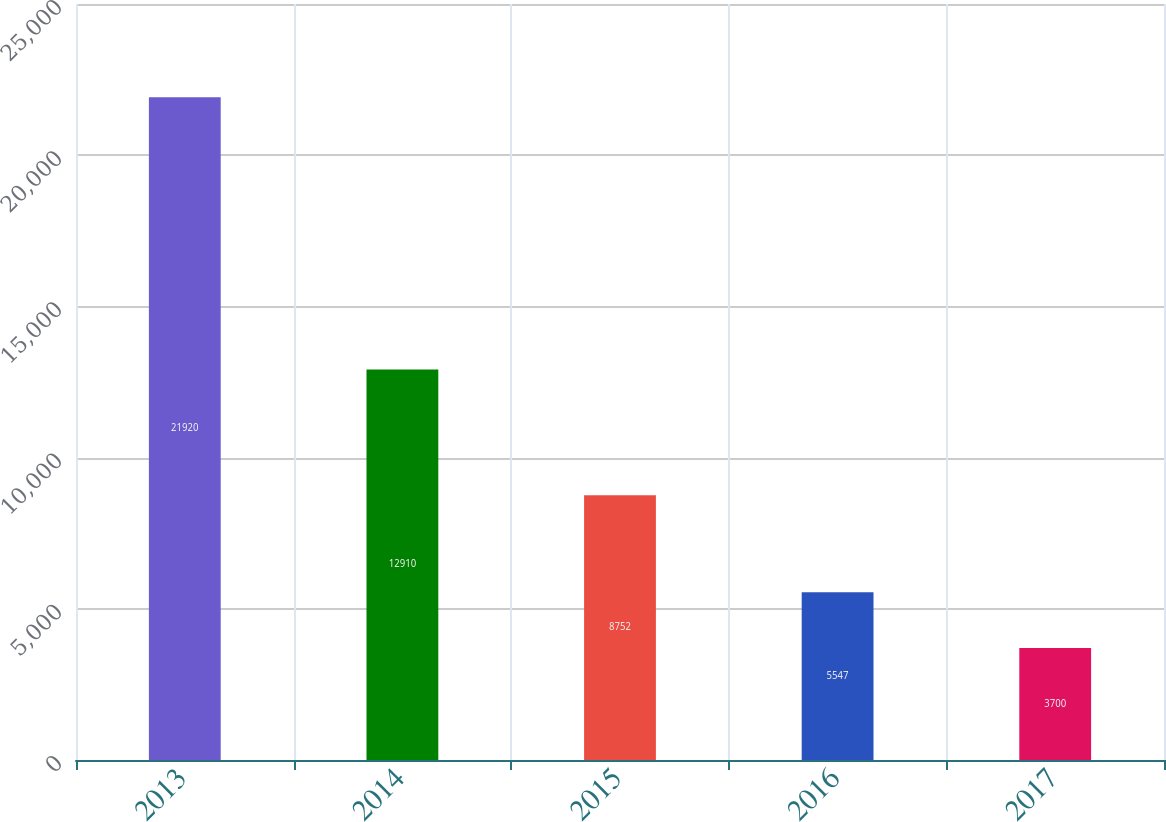Convert chart to OTSL. <chart><loc_0><loc_0><loc_500><loc_500><bar_chart><fcel>2013<fcel>2014<fcel>2015<fcel>2016<fcel>2017<nl><fcel>21920<fcel>12910<fcel>8752<fcel>5547<fcel>3700<nl></chart> 